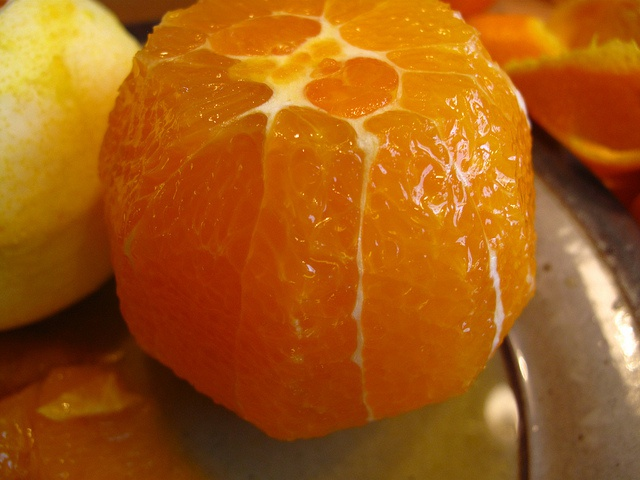Describe the objects in this image and their specific colors. I can see orange in maroon, red, and orange tones and orange in maroon, red, and orange tones in this image. 